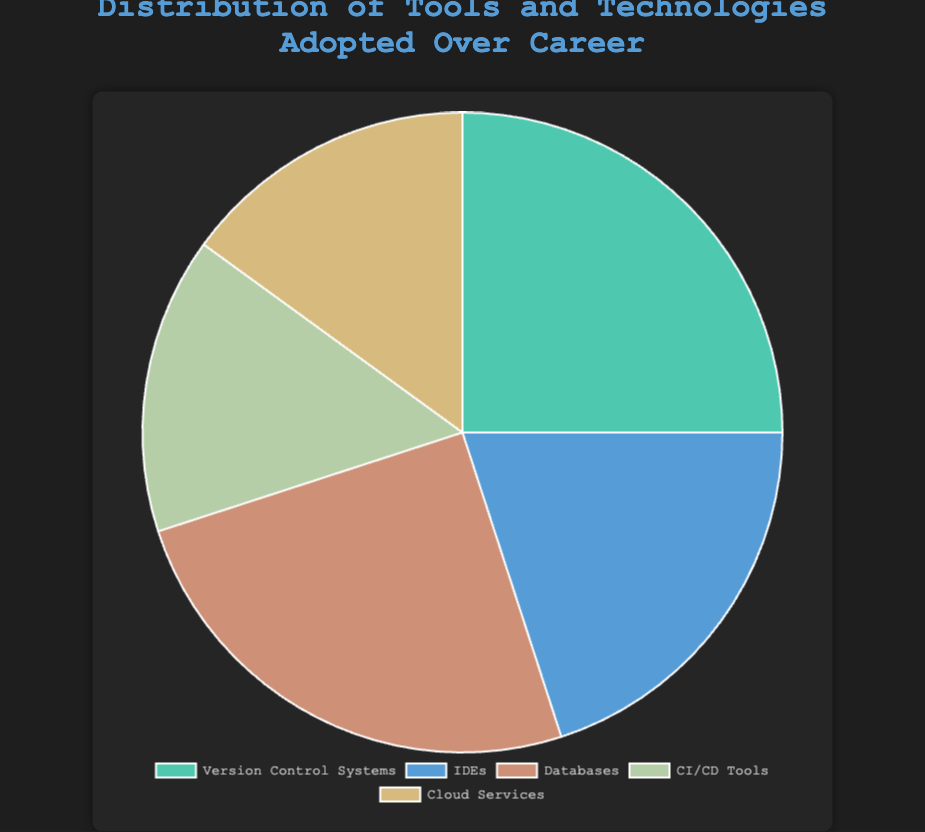What percentage of the tools and technologies adopted were for databases? The pie chart shows that databases account for 25% of the total distribution.
Answer: 25% Which section has the largest percentage? By visually inspecting the pie chart, the largest section is indicated as either Version Control Systems or Databases, both accounting for 25%.
Answer: Version Control Systems and Databases How much more is the percentage of data for version control systems compared to IDEs? The percentage for Version Control Systems is 25%, and for IDEs, it is 20%. The difference is 25% - 20% = 5%.
Answer: 5% Which two categories have the smallest distribution percentages? By inspecting the pie chart, CI/CD Tools and Cloud Services both have the smallest distribution percentages, each at 15%.
Answer: CI/CD Tools and Cloud Services Do CI/CD Tools and Cloud Services together account for a larger percentage than Version Control Systems alone? The combined percentage of CI/CD Tools and Cloud Services is 15% + 15% = 30%. This is larger than 25%, which is the percentage for Version Control Systems alone.
Answer: Yes What's the combined percentage of tools and technologies adopted for IDEs and Databases? IDEs account for 20% and Databases for 25%. Together, they sum up to 20% + 25% = 45%.
Answer: 45% Is the percentage for Cloud Services equal to that of CI/CD Tools? Both Cloud Services and CI/CD Tools each account for 15% of the distribution.
Answer: Yes Which category has the second largest distribution? After Version Control Systems and Databases, which are tied for the largest at 25%, IDEs follow with 20%. Hence, IDEs have the second largest distribution.
Answer: IDEs Are the Version Control Systems and Databases percentages together more than the remaining categories? The combined percentage for Version Control Systems and Databases is 25% + 25% = 50%. The remaining three categories are IDEs (20%), CI/CD Tools (15%), and Cloud Services (15%), which together sum up to 20% + 15% + 15% = 50%.
Answer: No Which section of the pie chart is represented by the color green? By observing the colors and their respective labels in the pie chart, the green-colored section denotes Version Control Systems.
Answer: Version Control Systems 